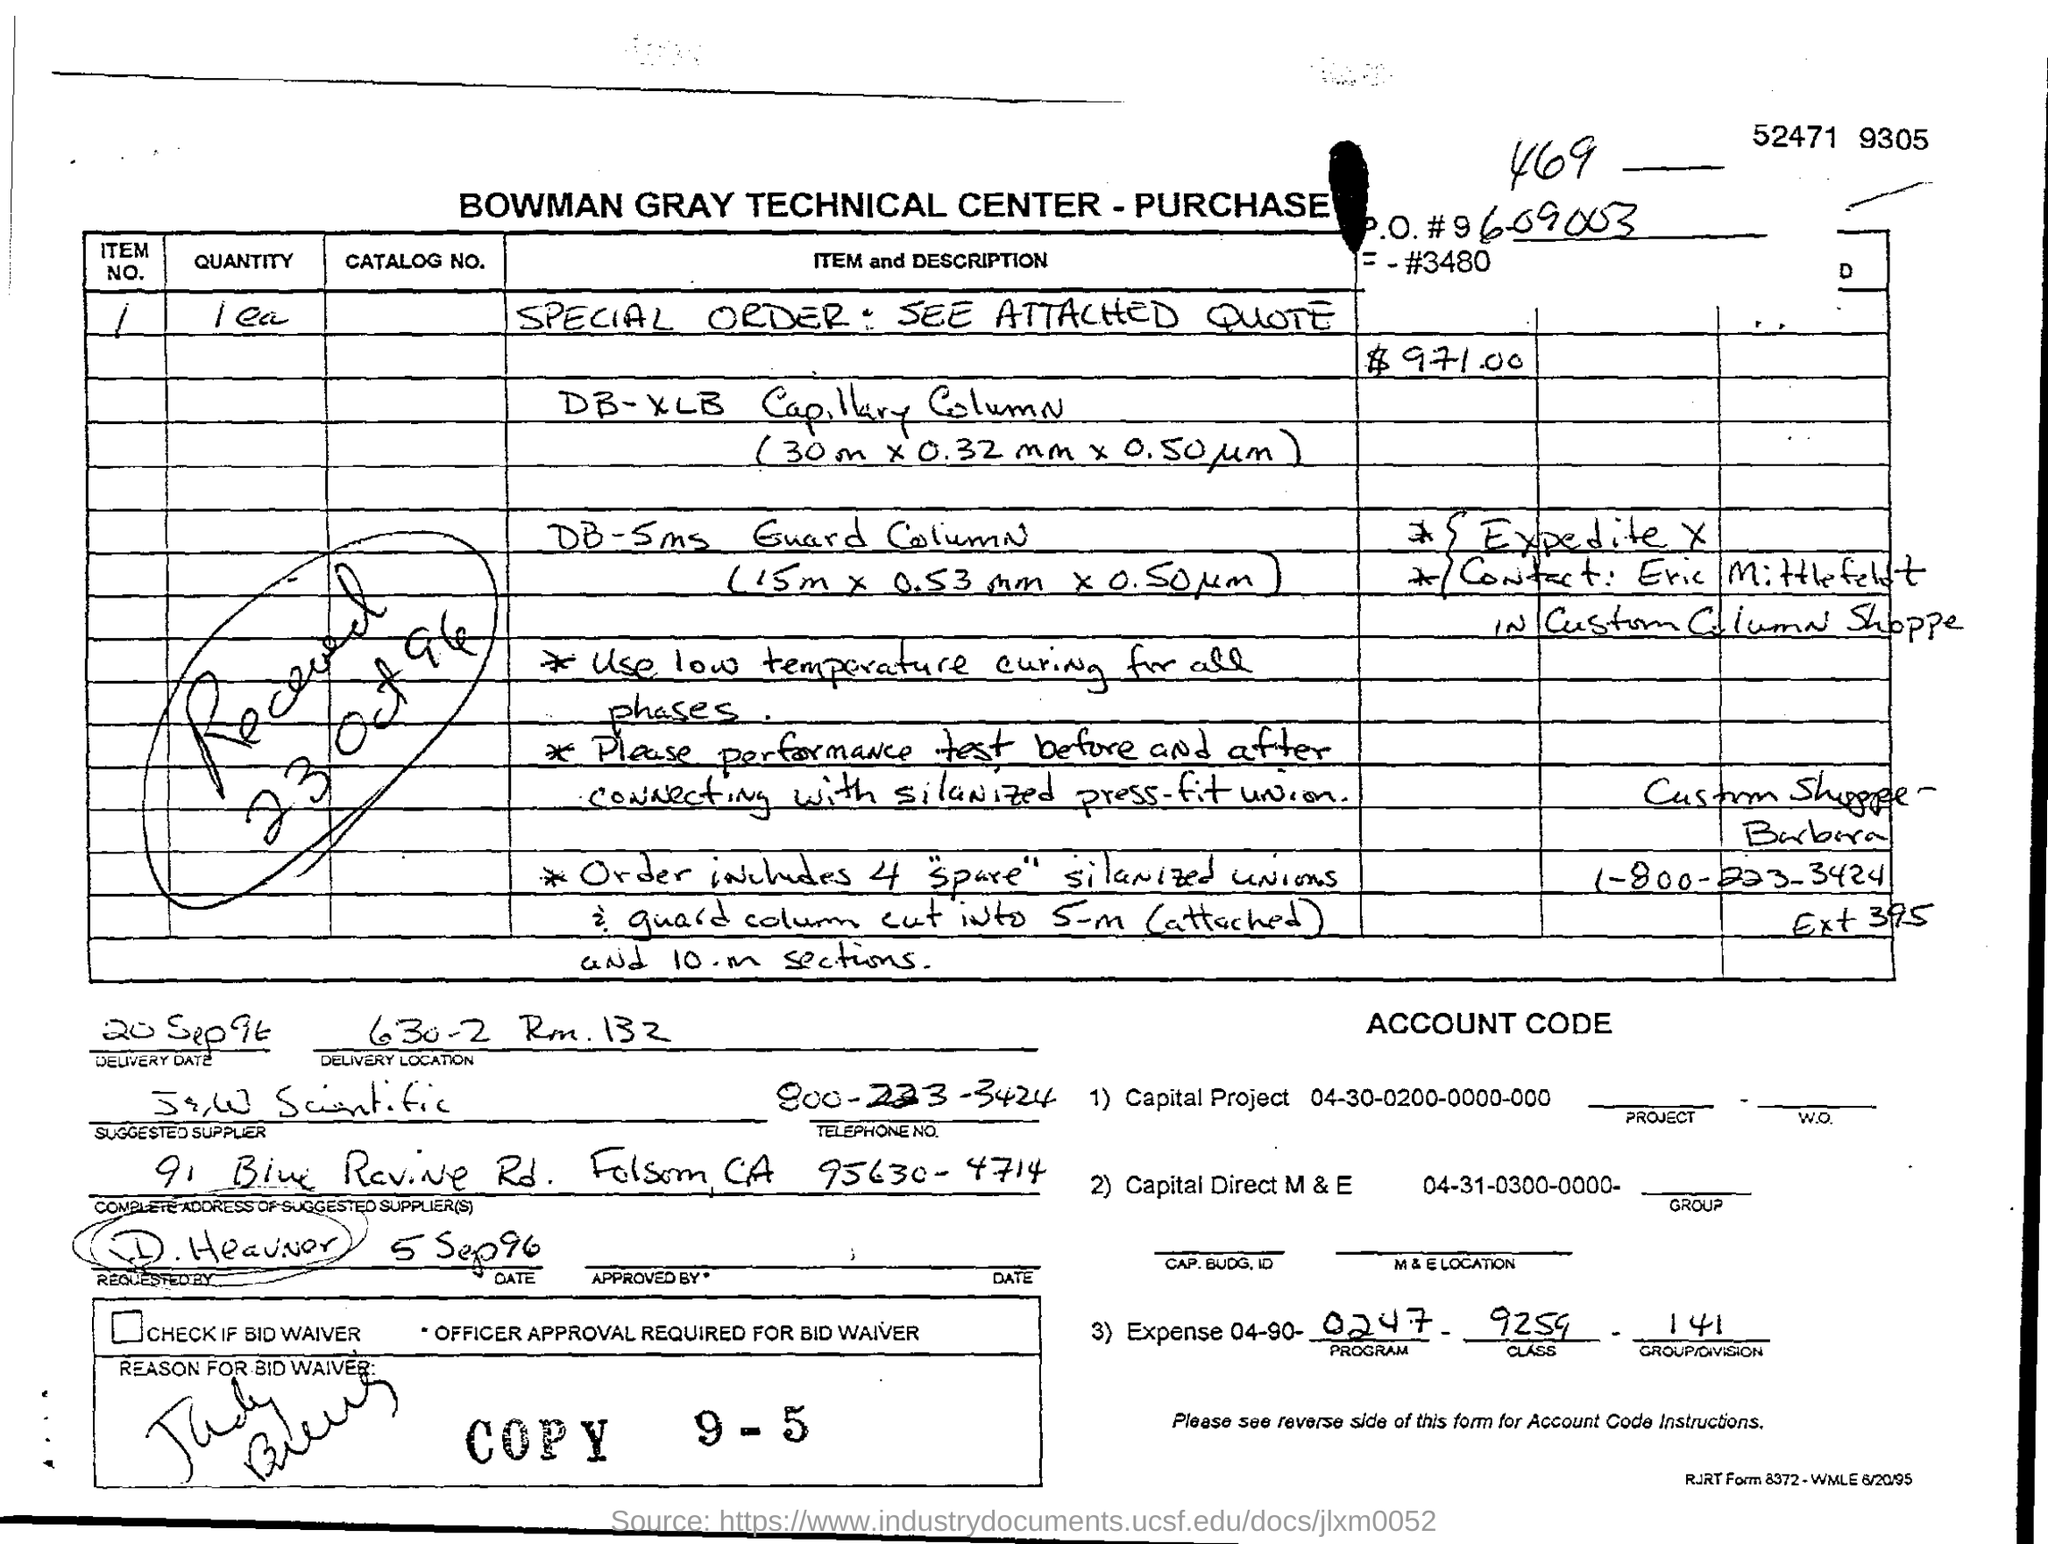Outline some significant characteristics in this image. The performance test of a press-fit union should be conducted by ensuring that the proper steps are taken before and after connecting it, including sanitization and adherence to manufacturer guidelines. Bowman Gray Technical Center is the recipient of the purchase order. The order was received on October 23, 1996. The order contains four silanized unions. The delivery date is September 20, 1996. 